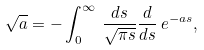<formula> <loc_0><loc_0><loc_500><loc_500>\sqrt { a } = - \int _ { 0 } ^ { \infty } \, \frac { d s } { \sqrt { \pi s } } \frac { d } { d s } \, e ^ { - a s } ,</formula> 